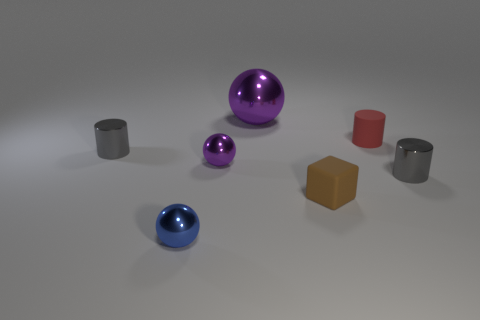What material is the tiny gray cylinder that is to the right of the purple shiny ball behind the tiny matte cylinder? metal 